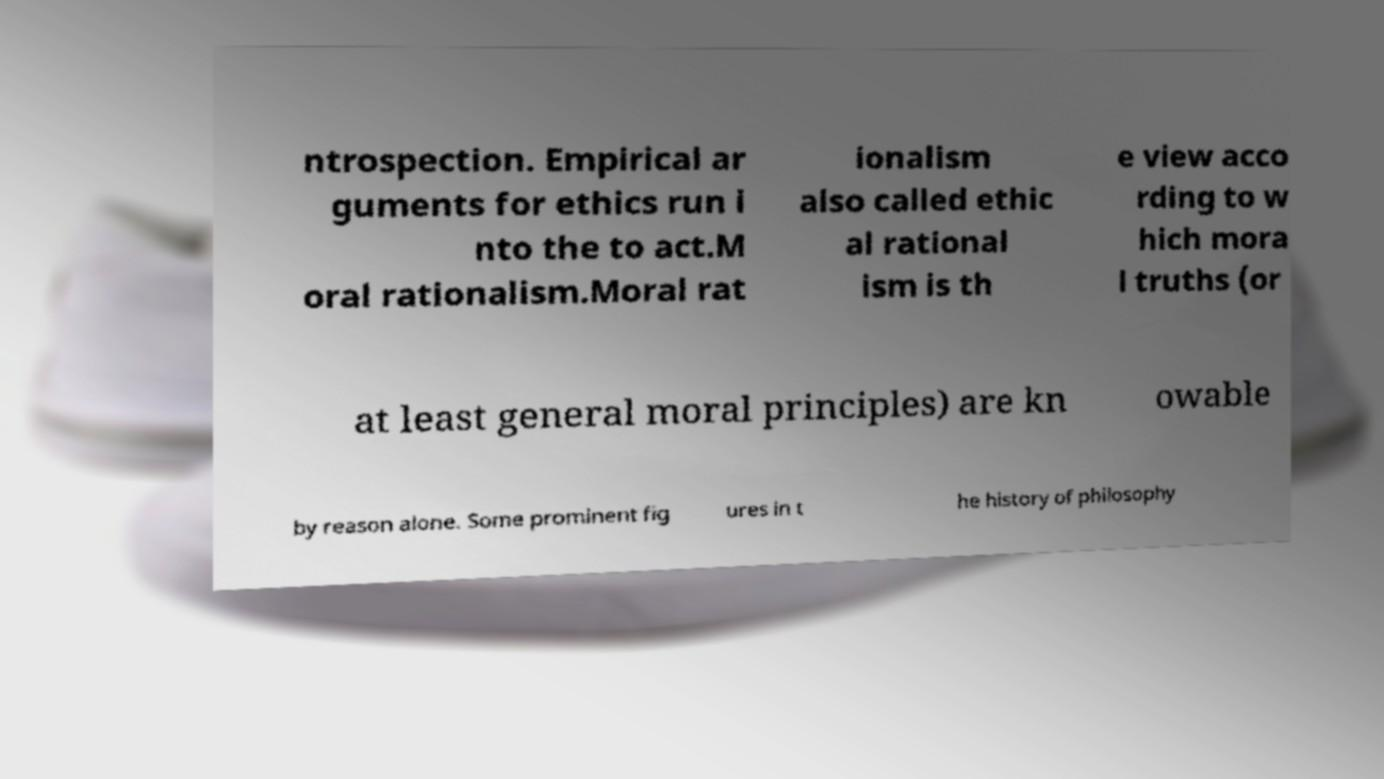Can you read and provide the text displayed in the image?This photo seems to have some interesting text. Can you extract and type it out for me? ntrospection. Empirical ar guments for ethics run i nto the to act.M oral rationalism.Moral rat ionalism also called ethic al rational ism is th e view acco rding to w hich mora l truths (or at least general moral principles) are kn owable by reason alone. Some prominent fig ures in t he history of philosophy 